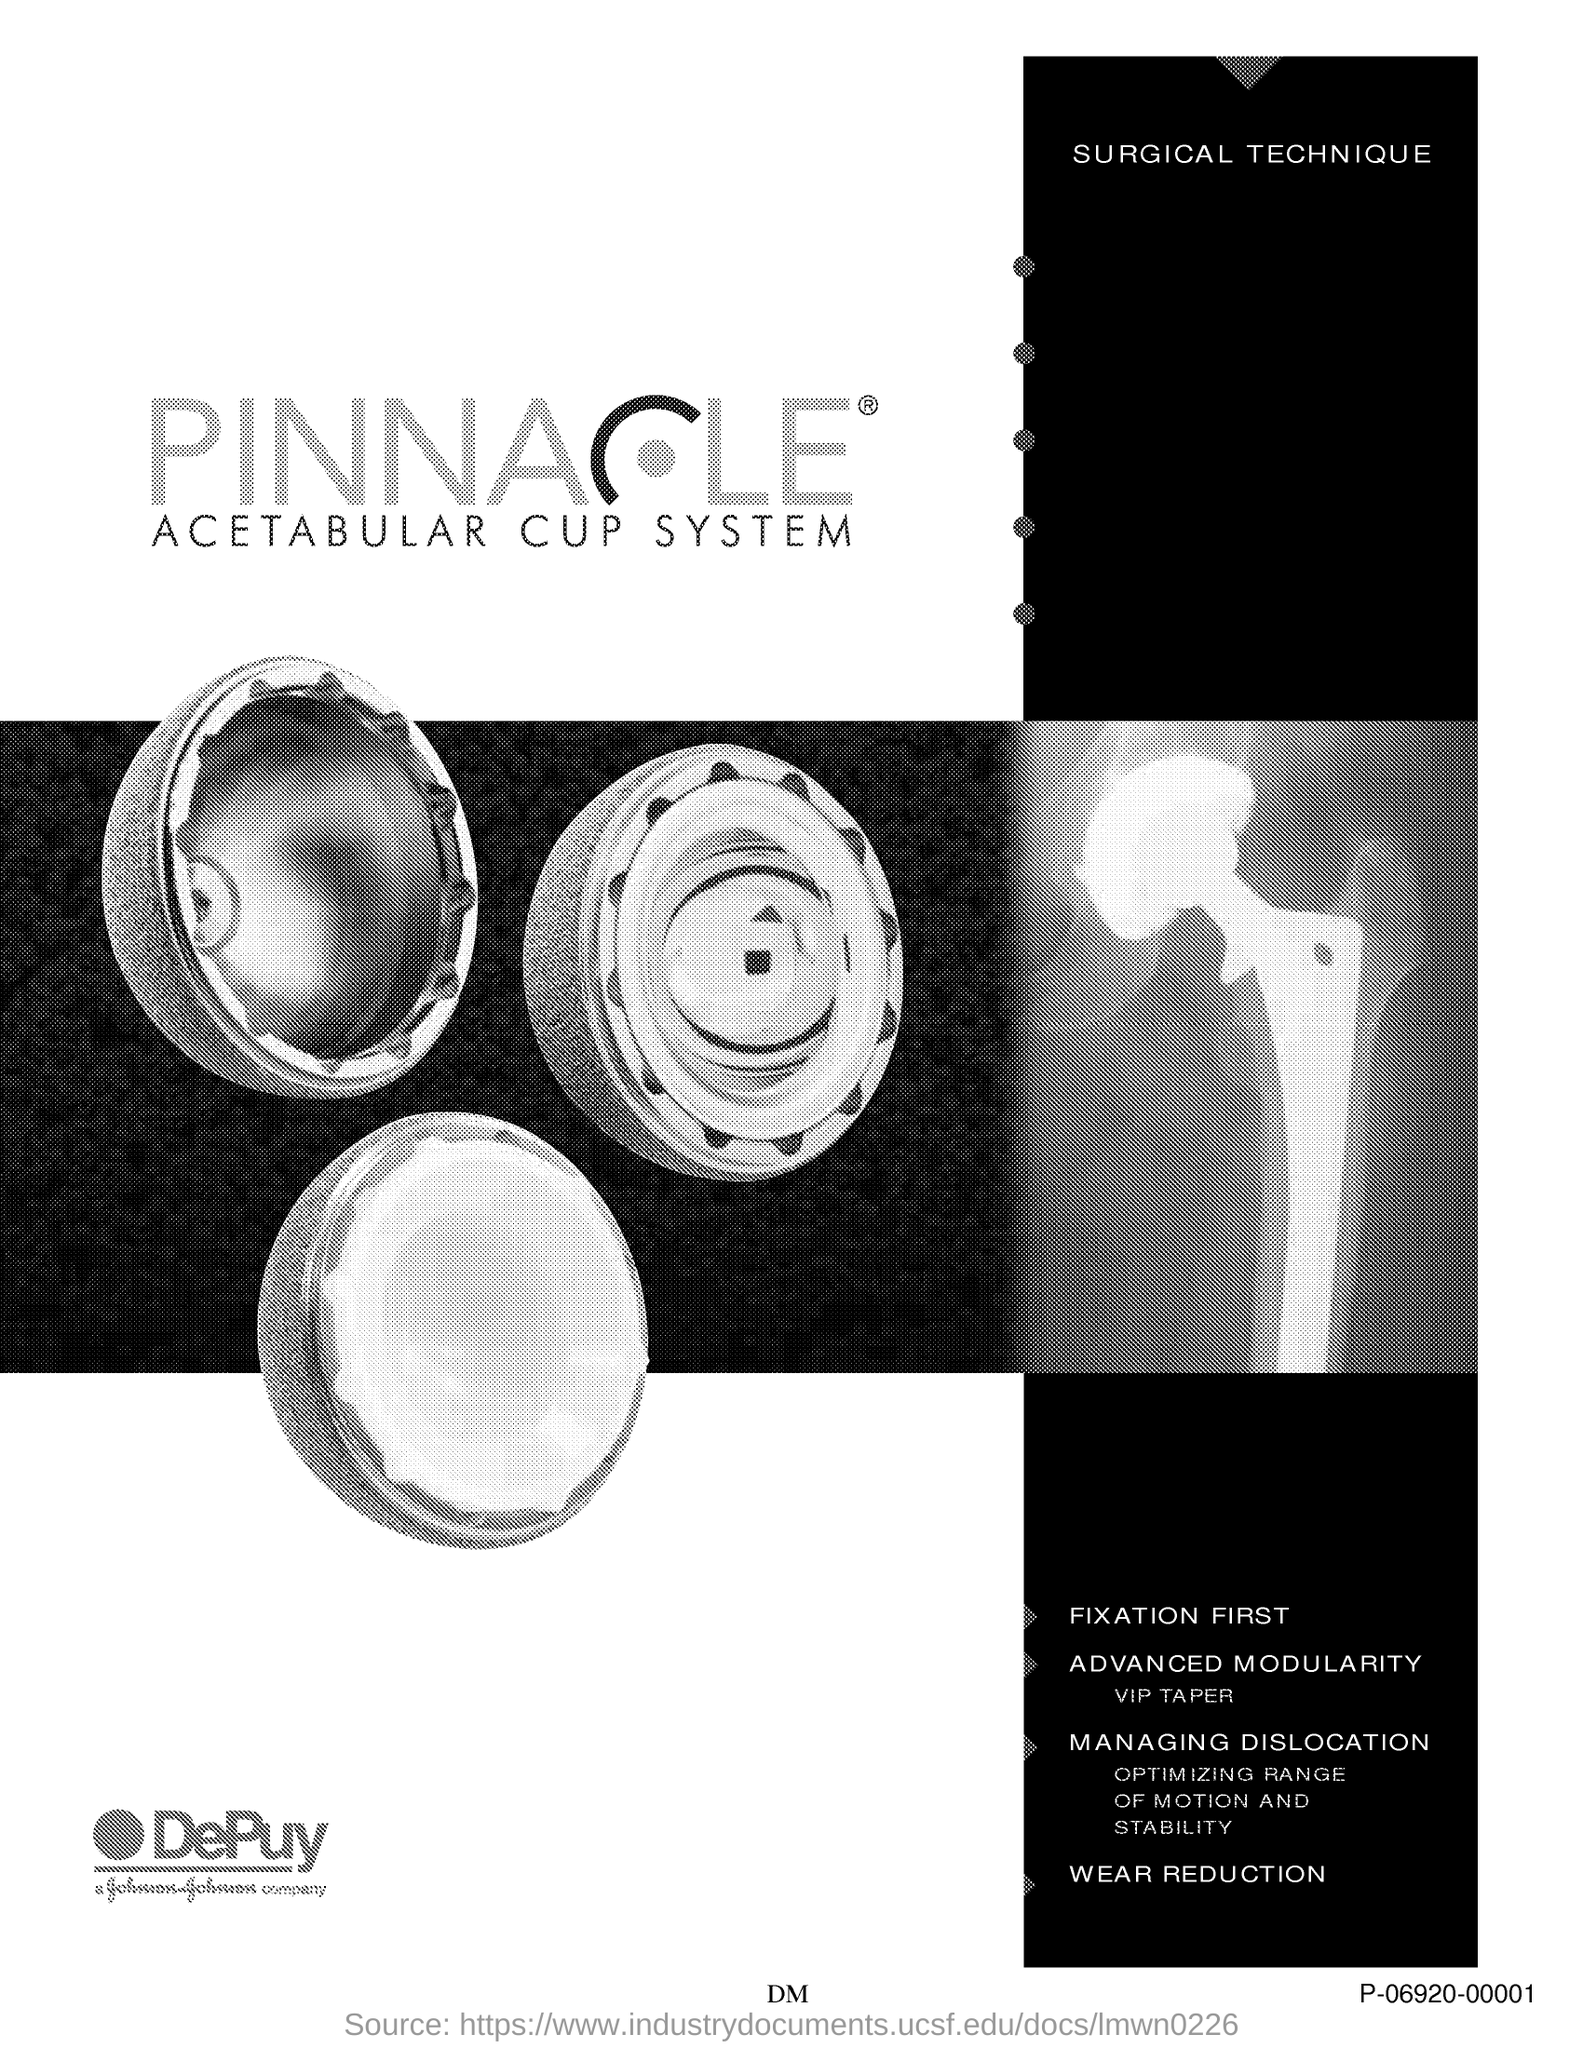Mention a couple of crucial points in this snapshot. The surgical technique mentioned in the document is a (adjective) method for (performing a surgical procedure/achieving a particular outcome). 